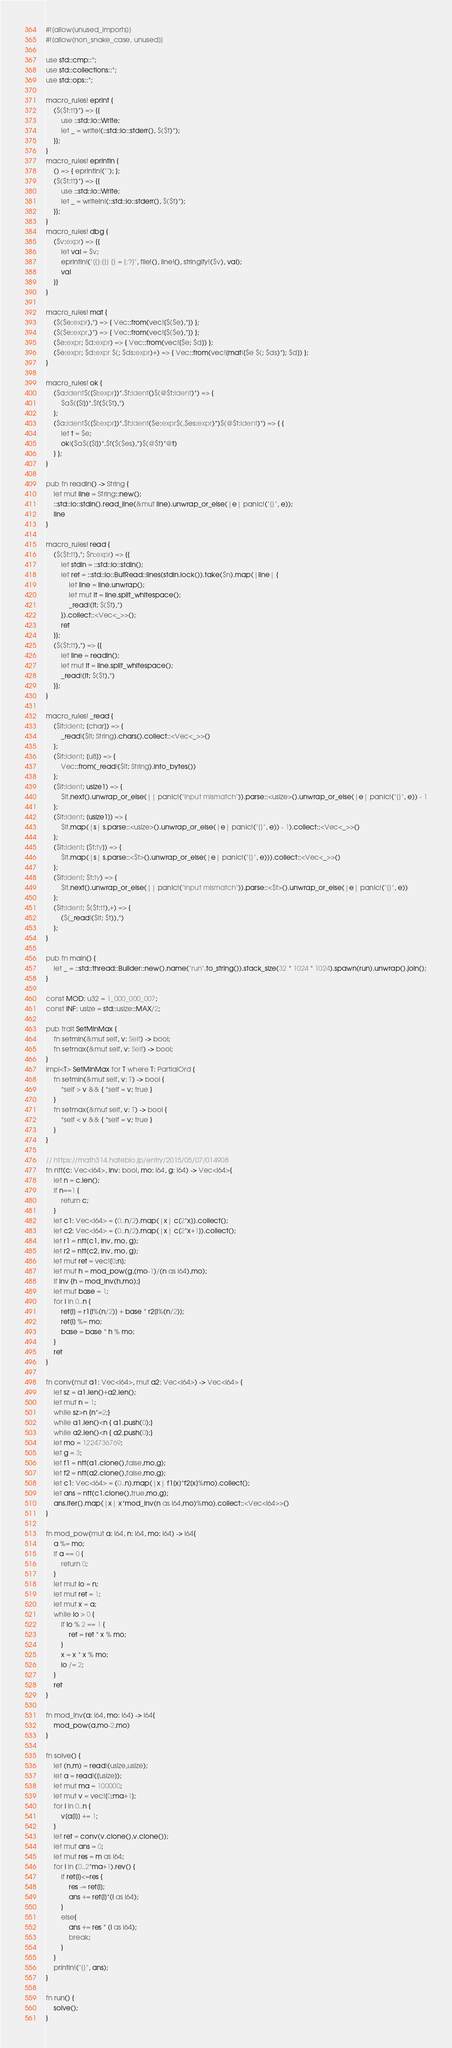<code> <loc_0><loc_0><loc_500><loc_500><_Rust_>#![allow(unused_imports)]
#![allow(non_snake_case, unused)]

use std::cmp::*;
use std::collections::*;
use std::ops::*;

macro_rules! eprint {
	($($t:tt)*) => {{
		use ::std::io::Write;
		let _ = write!(::std::io::stderr(), $($t)*);
	}};
}
macro_rules! eprintln {
	() => { eprintln!(""); };
	($($t:tt)*) => {{
		use ::std::io::Write;
		let _ = writeln!(::std::io::stderr(), $($t)*);
	}};
}
macro_rules! dbg {
	($v:expr) => {{
		let val = $v;
		eprintln!("[{}:{}] {} = {:?}", file!(), line!(), stringify!($v), val);
		val
	}}
}

macro_rules! mat {
	($($e:expr),*) => { Vec::from(vec![$($e),*]) };
	($($e:expr,)*) => { Vec::from(vec![$($e),*]) };
	($e:expr; $d:expr) => { Vec::from(vec![$e; $d]) };
	($e:expr; $d:expr $(; $ds:expr)+) => { Vec::from(vec![mat![$e $(; $ds)*]; $d]) };
}

macro_rules! ok {
	($a:ident$([$i:expr])*.$f:ident()$(@$t:ident)*) => {
		$a$([$i])*.$f($($t),*)
	};
	($a:ident$([$i:expr])*.$f:ident($e:expr$(,$es:expr)*)$(@$t:ident)*) => { {
		let t = $e;
		ok!($a$([$i])*.$f($($es),*)$(@$t)*@t)
	} };
}

pub fn readln() -> String {
	let mut line = String::new();
	::std::io::stdin().read_line(&mut line).unwrap_or_else(|e| panic!("{}", e));
	line
}

macro_rules! read {
	($($t:tt),*; $n:expr) => {{
		let stdin = ::std::io::stdin();
		let ret = ::std::io::BufRead::lines(stdin.lock()).take($n).map(|line| {
			let line = line.unwrap();
			let mut it = line.split_whitespace();
			_read!(it; $($t),*)
		}).collect::<Vec<_>>();
		ret
	}};
	($($t:tt),*) => {{
		let line = readln();
		let mut it = line.split_whitespace();
		_read!(it; $($t),*)
	}};
}

macro_rules! _read {
	($it:ident; [char]) => {
		_read!($it; String).chars().collect::<Vec<_>>()
	};
	($it:ident; [u8]) => {
		Vec::from(_read!($it; String).into_bytes())
	};
	($it:ident; usize1) => {
		$it.next().unwrap_or_else(|| panic!("input mismatch")).parse::<usize>().unwrap_or_else(|e| panic!("{}", e)) - 1
	};
	($it:ident; [usize1]) => {
		$it.map(|s| s.parse::<usize>().unwrap_or_else(|e| panic!("{}", e)) - 1).collect::<Vec<_>>()
	};
	($it:ident; [$t:ty]) => {
		$it.map(|s| s.parse::<$t>().unwrap_or_else(|e| panic!("{}", e))).collect::<Vec<_>>()
	};
	($it:ident; $t:ty) => {
		$it.next().unwrap_or_else(|| panic!("input mismatch")).parse::<$t>().unwrap_or_else(|e| panic!("{}", e))
	};
	($it:ident; $($t:tt),+) => {
		($(_read!($it; $t)),*)
	};
}

pub fn main() {
	let _ = ::std::thread::Builder::new().name("run".to_string()).stack_size(32 * 1024 * 1024).spawn(run).unwrap().join();
}

const MOD: u32 = 1_000_000_007;
const INF: usize = std::usize::MAX/2;

pub trait SetMinMax {
	fn setmin(&mut self, v: Self) -> bool;
	fn setmax(&mut self, v: Self) -> bool;
}
impl<T> SetMinMax for T where T: PartialOrd {
	fn setmin(&mut self, v: T) -> bool {
		*self > v && { *self = v; true }
	}
	fn setmax(&mut self, v: T) -> bool {
		*self < v && { *self = v; true }
	}
}

// https://math314.hateblo.jp/entry/2015/05/07/014908
fn ntt(c: Vec<i64>, inv: bool, mo: i64, g: i64) -> Vec<i64>{
    let n = c.len();
    if n==1 {
        return c;
    }
    let c1: Vec<i64> = (0..n/2).map(|x| c[2*x]).collect();
	let c2: Vec<i64> = (0..n/2).map(|x| c[2*x+1]).collect();
	let r1 = ntt(c1, inv, mo, g);
    let r2 = ntt(c2, inv, mo, g);
    let mut ret = vec![0;n];
	let mut h = mod_pow(g,(mo-1)/(n as i64),mo);
	if inv {h = mod_inv(h,mo);}
	let mut base = 1;
    for i in 0..n {
		ret[i] = r1[i%(n/2)] + base * r2[i%(n/2)];
		ret[i] %= mo;
		base = base * h % mo;
    }
    ret
}

fn conv(mut a1: Vec<i64>, mut a2: Vec<i64>) -> Vec<i64> {
    let sz = a1.len()+a2.len();
    let mut n = 1;
	while sz>n {n*=2;}
	while a1.len()<n { a1.push(0);}
	while a2.len()<n { a2.push(0);}
	let mo = 1224736769;
	let g = 3;
	let f1 = ntt(a1.clone(),false,mo,g);
	let f2 = ntt(a2.clone(),false,mo,g);
	let c1: Vec<i64> = (0..n).map(|x| f1[x]*f2[x]%mo).collect();
	let ans = ntt(c1.clone(),true,mo,g);
	ans.iter().map(|x| x*mod_inv(n as i64,mo)%mo).collect::<Vec<i64>>()
}

fn mod_pow(mut a: i64, n: i64, mo: i64) -> i64{
	a %= mo;
	if a == 0 {
		return 0;
	}
	let mut lo = n;
	let mut ret = 1;
	let mut x = a;
	while lo > 0 {
		if lo % 2 == 1 {
			ret = ret * x % mo;
		}
		x = x * x % mo;
		lo /= 2;
	}
	ret
}

fn mod_inv(a: i64, mo: i64) -> i64{
	mod_pow(a,mo-2,mo)
}

fn solve() {
	let (n,m) = read!(usize,usize);
	let a = read!([usize]);
	let mut ma = 100000;
	let mut v = vec![0;ma+1];
	for i in 0..n {
		v[a[i]] += 1;
	}
	let ret = conv(v.clone(),v.clone());
	let mut ans = 0;
	let mut res = m as i64;
	for i in (0..2*ma+1).rev() {
		if ret[i]<=res {
			res -= ret[i];
			ans += ret[i]*(i as i64);
		}
		else{
			ans += res * (i as i64);
			break;
		}
	}
	println!("{}", ans);
}

fn run() {
    solve();
}</code> 